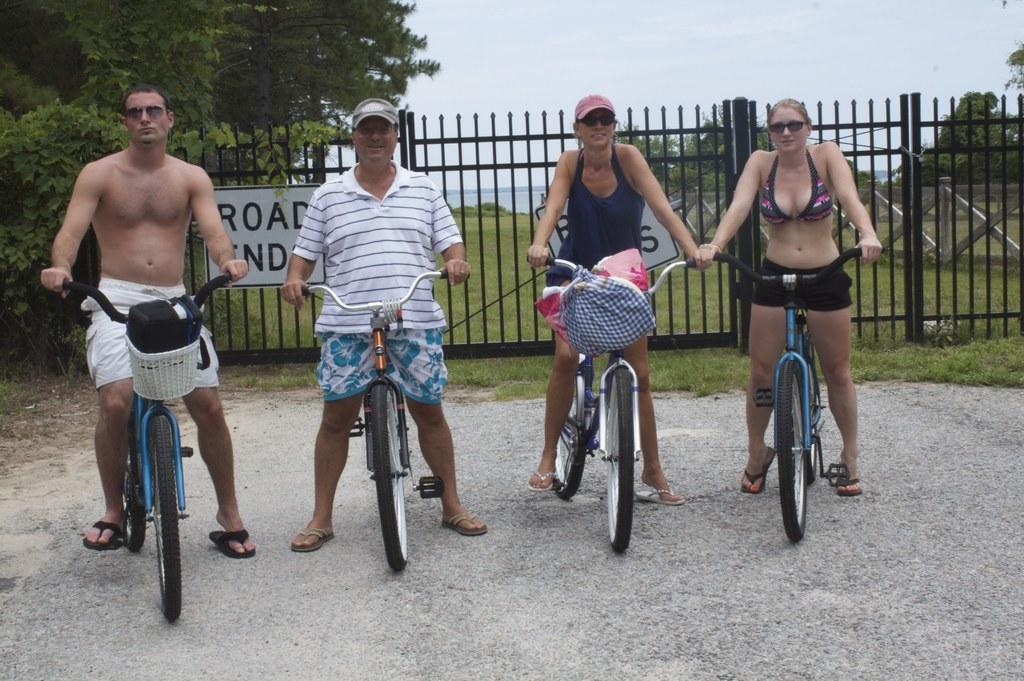Describe this image in one or two sentences. This image is clicked on the roads. There are four persons in this image. Two men and two women. To the left, the man is wearing white short and riding a bicycle. In the background, there are trees and green grass and fencing. At the bottom, there is road. 